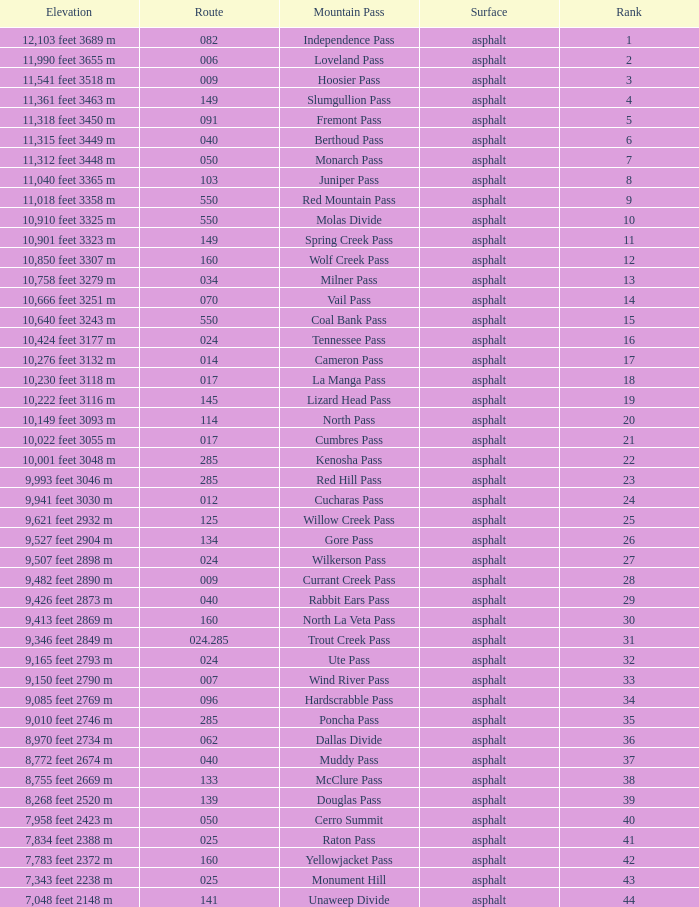On what Route is the mountain with a Rank less than 33 and an Elevation of 11,312 feet 3448 m? 50.0. 